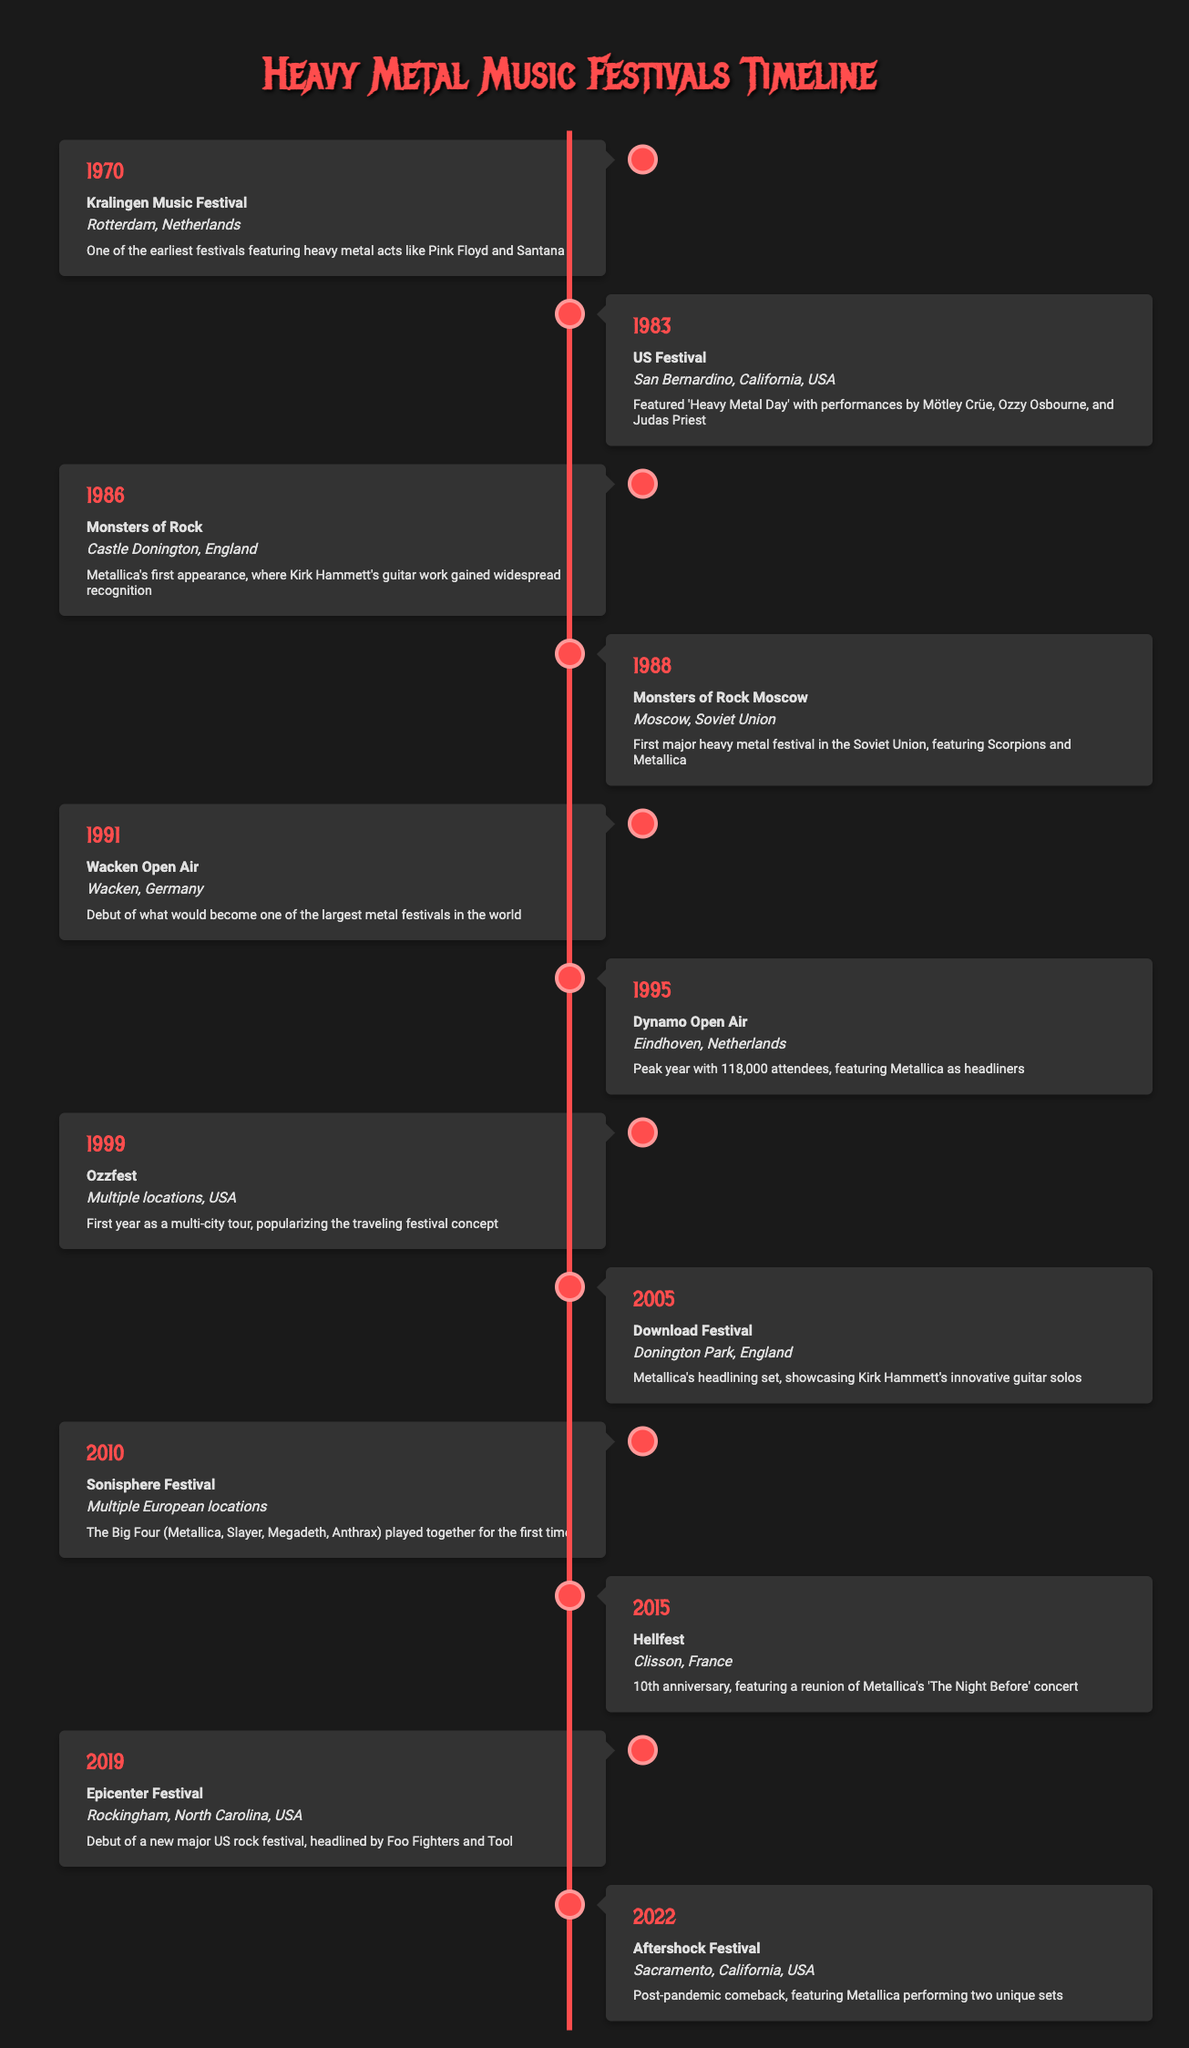What year did Metallica make their first appearance at a major festival? Metallica's first appearance at a major festival was in 1986 at the Monsters of Rock festival in Castle Donington, England. This fact can be found directly in the table under the year 1986.
Answer: 1986 How many festivals took place before the year 2000? According to the table, the festivals that took place before 2000 are: Kralingen Music Festival (1970), US Festival (1983), Monsters of Rock (1986), Monsters of Rock Moscow (1988), Wacken Open Air (1991), Dynamo Open Air (1995), and Ozzfest (1999). Counting these gives us 7 festivals.
Answer: 7 Was there a festival held in the Soviet Union? Yes, the table indicates that the Monsters of Rock Moscow festival was held in the Soviet Union in 1988, which was noted as the first major heavy metal festival there.
Answer: Yes Which festival featured Metallica as headliners with the highest number of attendees? In the data provided, the Dynamo Open Air festival held in 1995 in Eindhoven, Netherlands, had the highest attendance of 118,000, featuring Metallica as headliners. Therefore, it is the festival with the highest number of attendees.
Answer: Dynamo Open Air What is the difference in years between Metallica's first appearance and their headlining set at the Download Festival? Metallica's first appearance was in 1986, and their headlining set at the Download Festival was in 2005. The difference in years can be calculated by subtracting 1986 from 2005, which results in a difference of 19 years.
Answer: 19 What was notable about the Sonisphere Festival in 2010? The Sonisphere Festival in 2010 is notable for being the first time that the Big Four of thrash metal (Metallica, Slayer, Megadeth, and Anthrax) played together at a festival. This significant collaboration is highlighted in the description of the event in the table.
Answer: Big Four played together Which festival had the most recent date listed in the table? The most recent festival listed in the table is the Aftershock Festival, which took place in 2022 according to the data provided.
Answer: 2022 How many festivals took place in the 1990s according to the table? The festivals listed in the 1990s are: Wacken Open Air (1991), Dynamo Open Air (1995), and Ozzfest (1999). Therefore, there were 3 festivals that took place in the 1990s.
Answer: 3 In which festival did Kirk Hammett's guitar work gain widespread recognition? According to the table, Kirk Hammett's guitar work gained widespread recognition during Metallica's first appearance at the Monsters of Rock festival in 1986, held in Castle Donington, England.
Answer: Monsters of Rock 